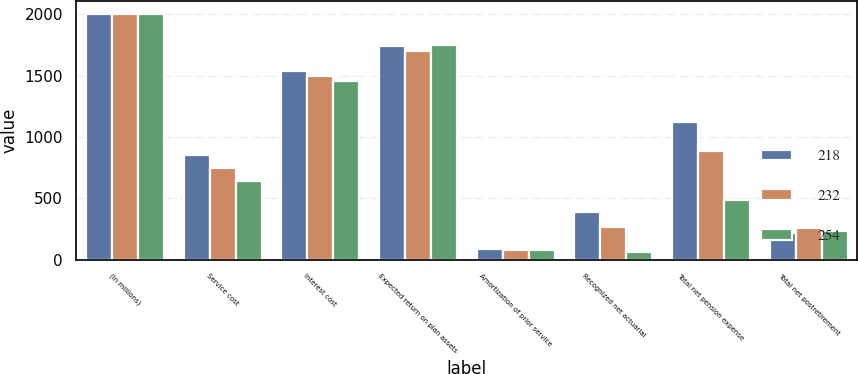<chart> <loc_0><loc_0><loc_500><loc_500><stacked_bar_chart><ecel><fcel>(In millions)<fcel>Service cost<fcel>Interest cost<fcel>Expected return on plan assets<fcel>Amortization of prior service<fcel>Recognized net actuarial<fcel>Total net pension expense<fcel>Total net postretirement<nl><fcel>218<fcel>2005<fcel>852<fcel>1535<fcel>1740<fcel>85<fcel>392<fcel>1124<fcel>218<nl><fcel>232<fcel>2004<fcel>743<fcel>1497<fcel>1698<fcel>78<fcel>264<fcel>884<fcel>254<nl><fcel>254<fcel>2003<fcel>640<fcel>1453<fcel>1748<fcel>77<fcel>62<fcel>484<fcel>232<nl></chart> 